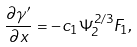Convert formula to latex. <formula><loc_0><loc_0><loc_500><loc_500>\frac { \partial \gamma ^ { \prime } } { \partial x } = - c _ { 1 } \Psi _ { 2 } ^ { 2 / 3 } F _ { 1 } ,</formula> 